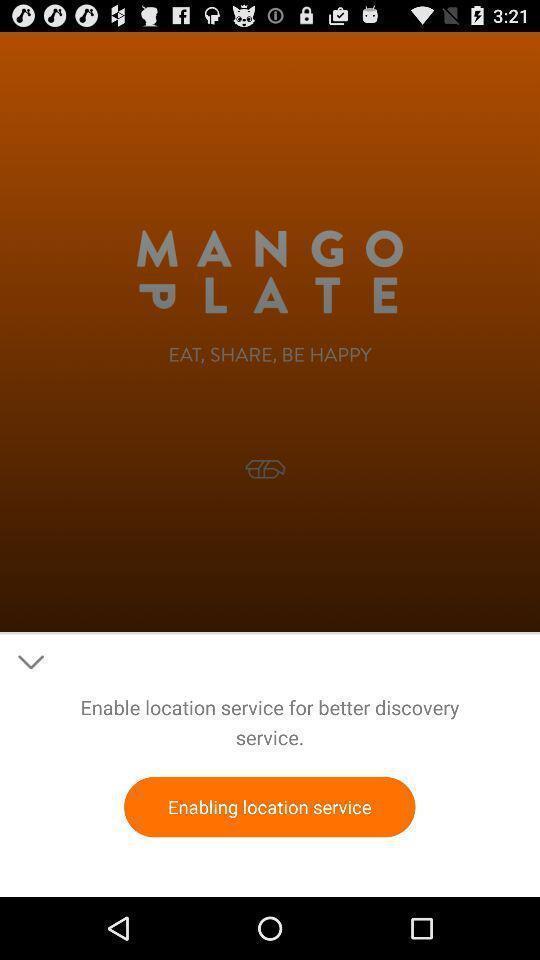Give me a narrative description of this picture. Screen displaying navigation feature in a food application. 